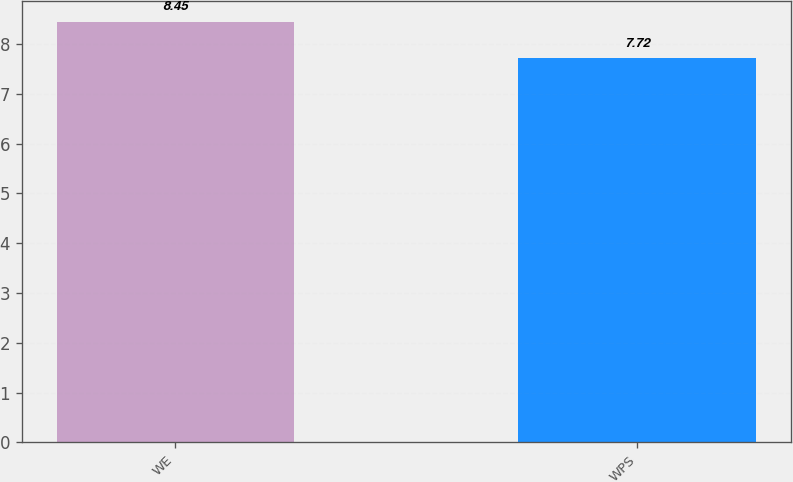<chart> <loc_0><loc_0><loc_500><loc_500><bar_chart><fcel>WE<fcel>WPS<nl><fcel>8.45<fcel>7.72<nl></chart> 